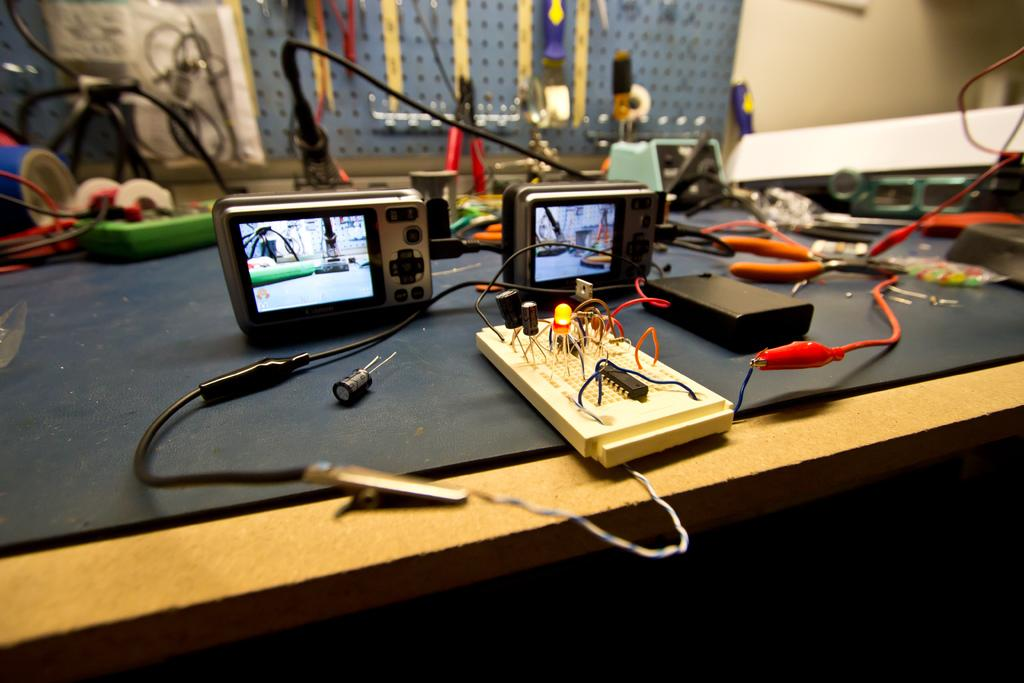What type of furniture is present in the image? There is a table in the image. What is placed on the table? There are electronic devices on the table. What event led to the discovery of the new electronic device in the image? There is no event mentioned in the image, nor is there any indication of a new electronic device being discovered. 